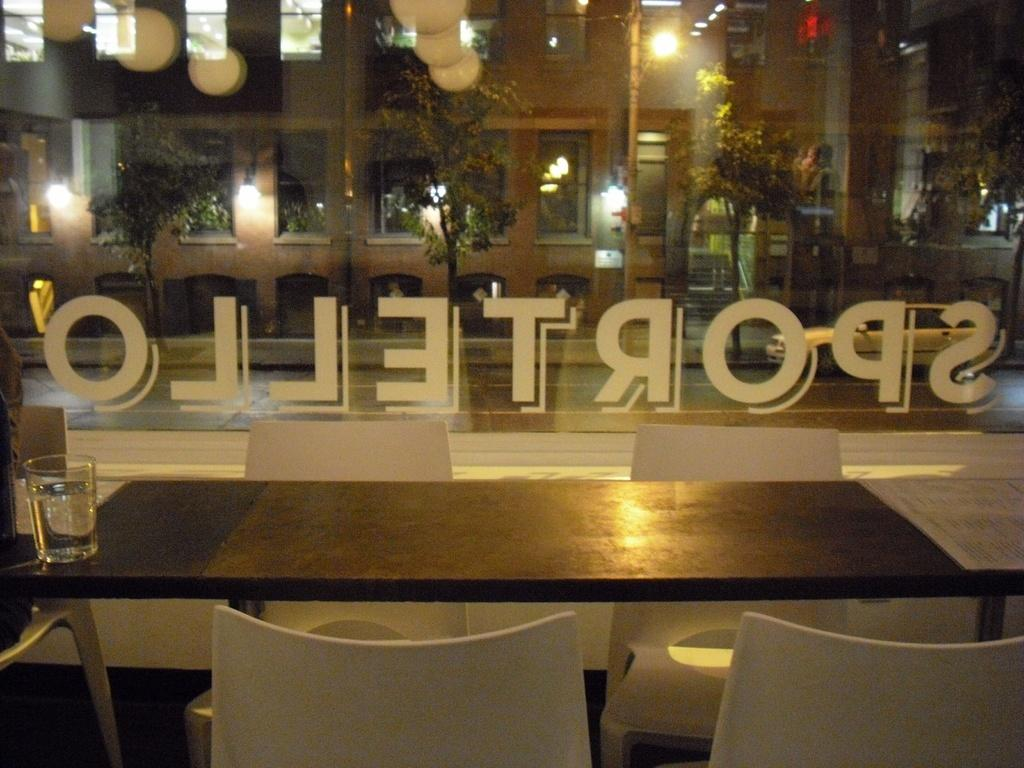What type of furniture is in the center of the image? There is a dining table in the image. What accompanies the dining table? There are chairs around the dining table. What can be seen on the dining table? There is a glass of water on the dining table. What is visible through the window in the image? Trees and a building are visible outside the window. What type of cast can be seen on the person's arm in the image? There is no person with a cast present in the image; it only features a dining table, chairs, a glass of water, a window, trees, and a building. 